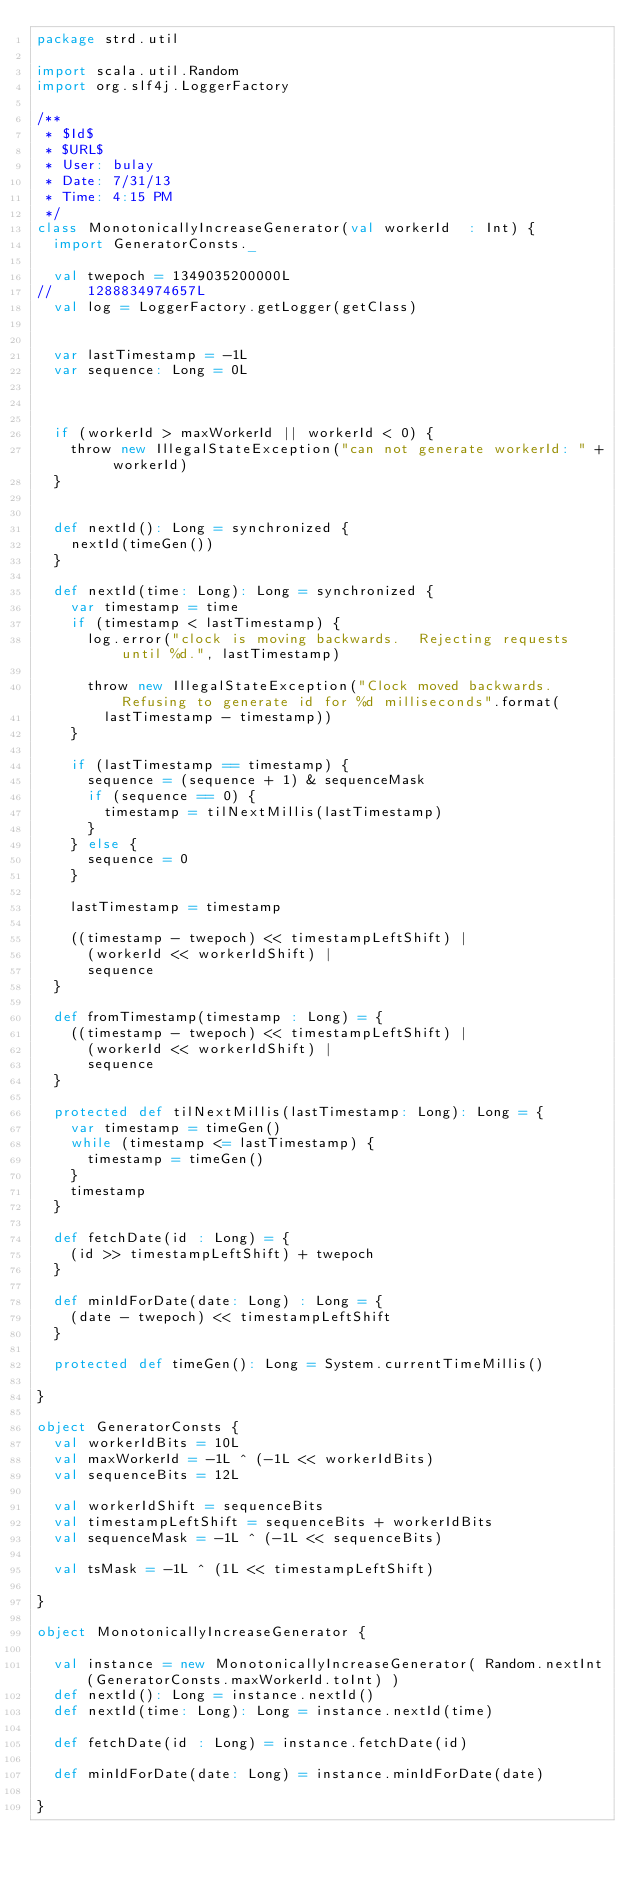<code> <loc_0><loc_0><loc_500><loc_500><_Scala_>package strd.util

import scala.util.Random
import org.slf4j.LoggerFactory

/**
 * $Id$
 * $URL$
 * User: bulay
 * Date: 7/31/13
 * Time: 4:15 PM
 */
class MonotonicallyIncreaseGenerator(val workerId  : Int) {
  import GeneratorConsts._

  val twepoch = 1349035200000L
//    1288834974657L
  val log = LoggerFactory.getLogger(getClass)


  var lastTimestamp = -1L
  var sequence: Long = 0L



  if (workerId > maxWorkerId || workerId < 0) {
    throw new IllegalStateException("can not generate workerId: " + workerId)
  }


  def nextId(): Long = synchronized {
    nextId(timeGen())
  }

  def nextId(time: Long): Long = synchronized {
    var timestamp = time
    if (timestamp < lastTimestamp) {
      log.error("clock is moving backwards.  Rejecting requests until %d.", lastTimestamp)

      throw new IllegalStateException("Clock moved backwards.  Refusing to generate id for %d milliseconds".format(
        lastTimestamp - timestamp))
    }

    if (lastTimestamp == timestamp) {
      sequence = (sequence + 1) & sequenceMask
      if (sequence == 0) {
        timestamp = tilNextMillis(lastTimestamp)
      }
    } else {
      sequence = 0
    }

    lastTimestamp = timestamp

    ((timestamp - twepoch) << timestampLeftShift) |
      (workerId << workerIdShift) |
      sequence
  }

  def fromTimestamp(timestamp : Long) = {
    ((timestamp - twepoch) << timestampLeftShift) |
      (workerId << workerIdShift) |
      sequence
  }

  protected def tilNextMillis(lastTimestamp: Long): Long = {
    var timestamp = timeGen()
    while (timestamp <= lastTimestamp) {
      timestamp = timeGen()
    }
    timestamp
  }

  def fetchDate(id : Long) = {
    (id >> timestampLeftShift) + twepoch
  }

  def minIdForDate(date: Long) : Long = {
    (date - twepoch) << timestampLeftShift
  }

  protected def timeGen(): Long = System.currentTimeMillis()

}

object GeneratorConsts {
  val workerIdBits = 10L
  val maxWorkerId = -1L ^ (-1L << workerIdBits)
  val sequenceBits = 12L

  val workerIdShift = sequenceBits
  val timestampLeftShift = sequenceBits + workerIdBits
  val sequenceMask = -1L ^ (-1L << sequenceBits)

  val tsMask = -1L ^ (1L << timestampLeftShift)

}

object MonotonicallyIncreaseGenerator {

  val instance = new MonotonicallyIncreaseGenerator( Random.nextInt(GeneratorConsts.maxWorkerId.toInt) )
  def nextId(): Long = instance.nextId()
  def nextId(time: Long): Long = instance.nextId(time)

  def fetchDate(id : Long) = instance.fetchDate(id)

  def minIdForDate(date: Long) = instance.minIdForDate(date)

}

</code> 